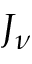Convert formula to latex. <formula><loc_0><loc_0><loc_500><loc_500>J _ { \nu }</formula> 